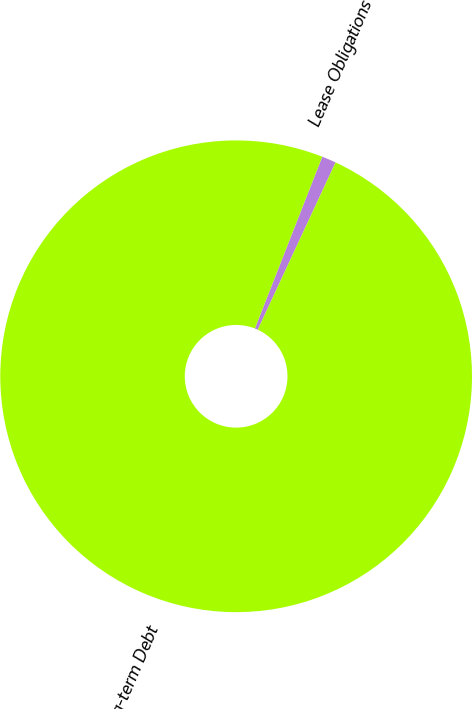Convert chart to OTSL. <chart><loc_0><loc_0><loc_500><loc_500><pie_chart><fcel>Lease Obligations<fcel>Long-term Debt<nl><fcel>0.98%<fcel>99.02%<nl></chart> 